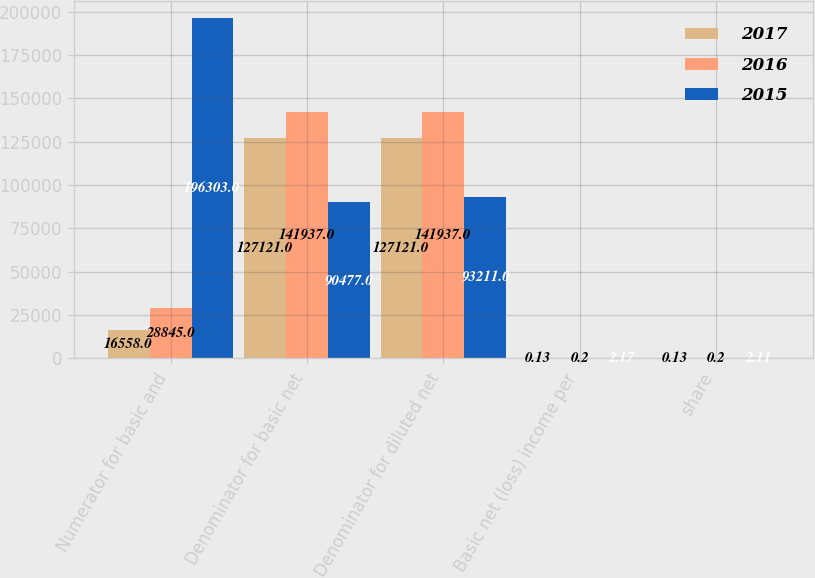Convert chart. <chart><loc_0><loc_0><loc_500><loc_500><stacked_bar_chart><ecel><fcel>Numerator for basic and<fcel>Denominator for basic net<fcel>Denominator for diluted net<fcel>Basic net (loss) income per<fcel>share<nl><fcel>2017<fcel>16558<fcel>127121<fcel>127121<fcel>0.13<fcel>0.13<nl><fcel>2016<fcel>28845<fcel>141937<fcel>141937<fcel>0.2<fcel>0.2<nl><fcel>2015<fcel>196303<fcel>90477<fcel>93211<fcel>2.17<fcel>2.11<nl></chart> 